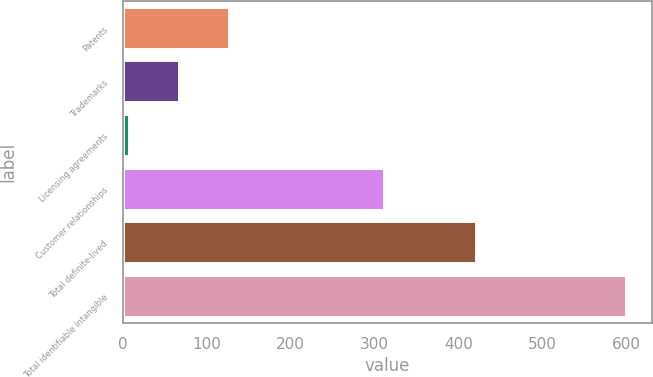Convert chart. <chart><loc_0><loc_0><loc_500><loc_500><bar_chart><fcel>Patents<fcel>Trademarks<fcel>Licensing agreements<fcel>Customer relationships<fcel>Total definite-lived<fcel>Total identifiable intangible<nl><fcel>127.18<fcel>67.99<fcel>8.8<fcel>312.3<fcel>421.9<fcel>600.7<nl></chart> 